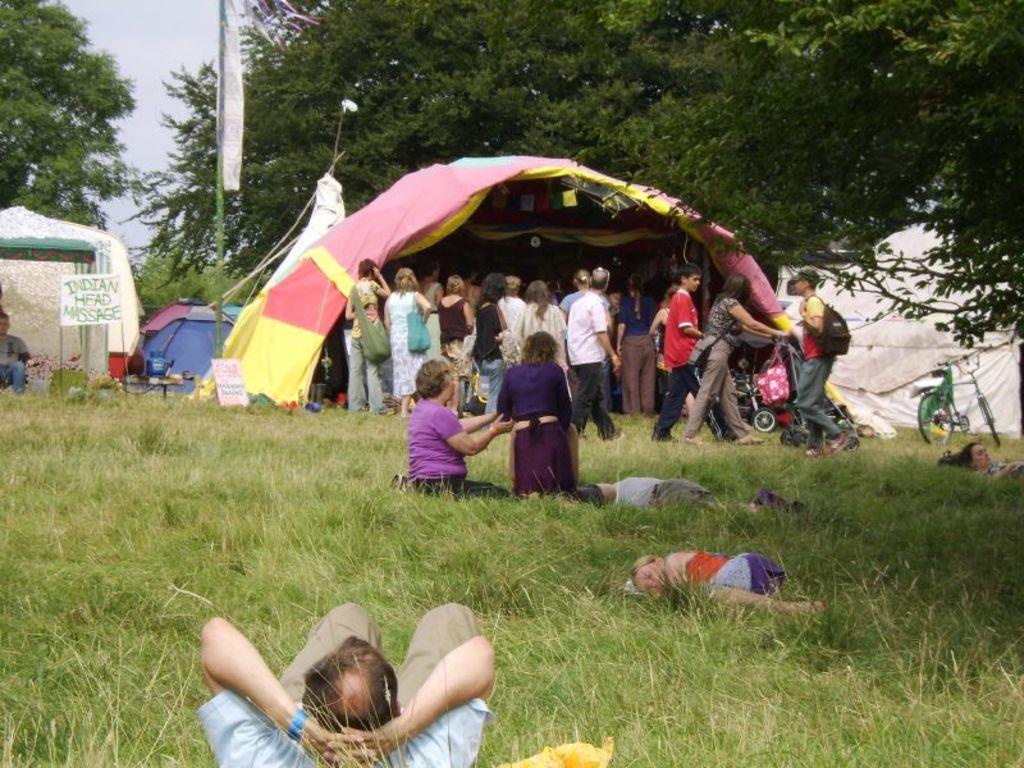How would you summarize this image in a sentence or two? In this image we can see people, grass, bicycle, pole, boards, banner, tents, trees, and sky. 